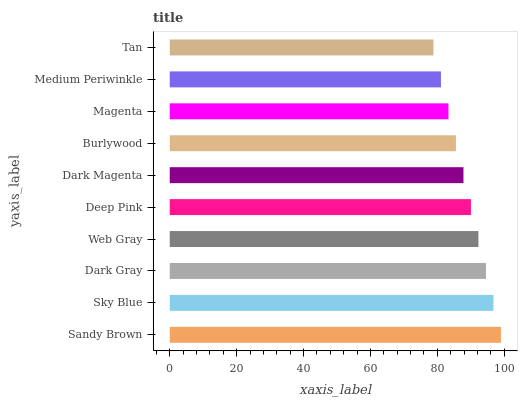Is Tan the minimum?
Answer yes or no. Yes. Is Sandy Brown the maximum?
Answer yes or no. Yes. Is Sky Blue the minimum?
Answer yes or no. No. Is Sky Blue the maximum?
Answer yes or no. No. Is Sandy Brown greater than Sky Blue?
Answer yes or no. Yes. Is Sky Blue less than Sandy Brown?
Answer yes or no. Yes. Is Sky Blue greater than Sandy Brown?
Answer yes or no. No. Is Sandy Brown less than Sky Blue?
Answer yes or no. No. Is Deep Pink the high median?
Answer yes or no. Yes. Is Dark Magenta the low median?
Answer yes or no. Yes. Is Web Gray the high median?
Answer yes or no. No. Is Dark Gray the low median?
Answer yes or no. No. 